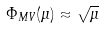Convert formula to latex. <formula><loc_0><loc_0><loc_500><loc_500>\Phi _ { M V } ( \mu ) \approx \sqrt { \mu }</formula> 